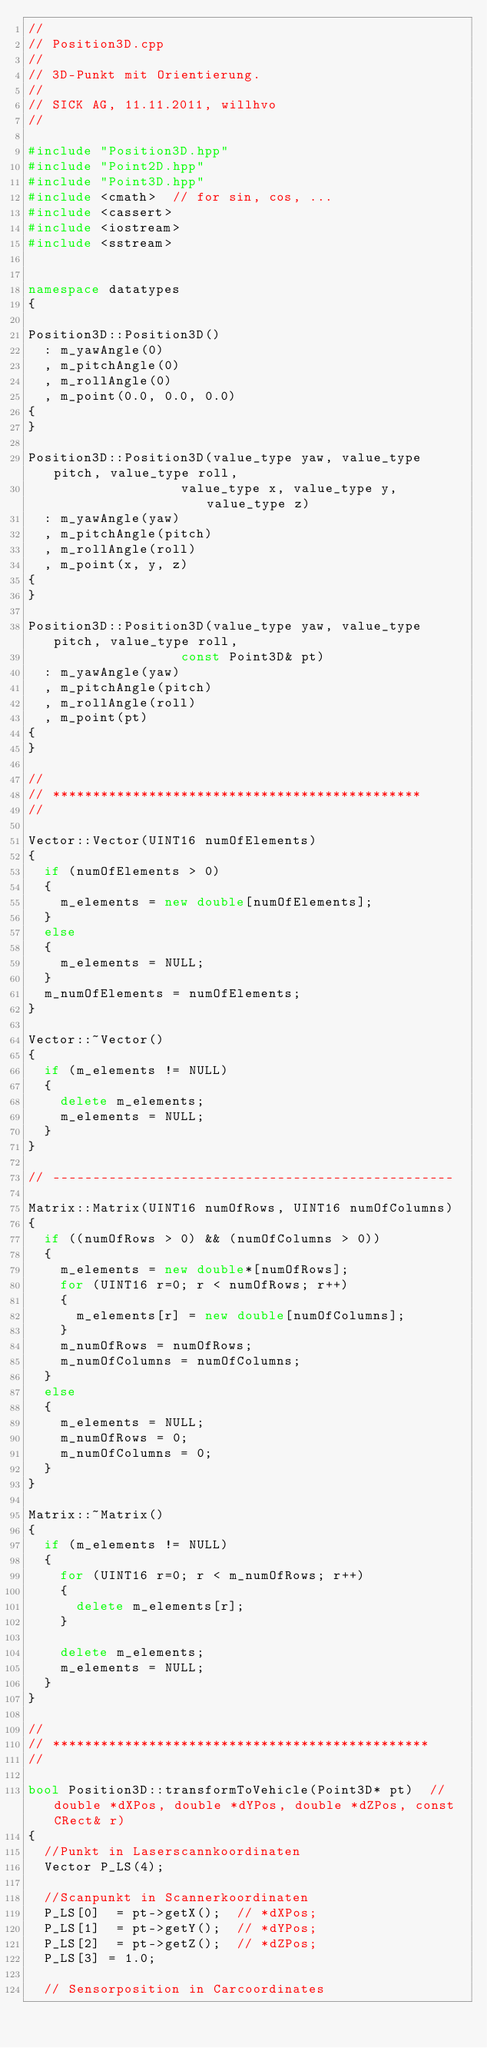Convert code to text. <code><loc_0><loc_0><loc_500><loc_500><_C++_>//
// Position3D.cpp
//
// 3D-Punkt mit Orientierung.
//
// SICK AG, 11.11.2011, willhvo
//

#include "Position3D.hpp"
#include "Point2D.hpp"
#include "Point3D.hpp"
#include <cmath>  // for sin, cos, ...
#include <cassert>
#include <iostream>
#include <sstream>


namespace datatypes
{
  
Position3D::Position3D()
  : m_yawAngle(0)
  , m_pitchAngle(0)
  , m_rollAngle(0)
  , m_point(0.0, 0.0, 0.0)
{
}

Position3D::Position3D(value_type yaw, value_type pitch, value_type roll,
                   value_type x, value_type y, value_type z)
  : m_yawAngle(yaw)
  , m_pitchAngle(pitch)
  , m_rollAngle(roll)
  , m_point(x, y, z)
{
}

Position3D::Position3D(value_type yaw, value_type pitch, value_type roll,
                   const Point3D& pt)
  : m_yawAngle(yaw)
  , m_pitchAngle(pitch)
  , m_rollAngle(roll)
  , m_point(pt)
{
}

//
// **********************************************
//

Vector::Vector(UINT16 numOfElements)
{
  if (numOfElements > 0)
  {
    m_elements = new double[numOfElements];
  }
  else
  {
    m_elements = NULL;
  }
  m_numOfElements = numOfElements;
}

Vector::~Vector()
{
  if (m_elements != NULL)
  {
    delete m_elements;
    m_elements = NULL;
  }
}

// --------------------------------------------------

Matrix::Matrix(UINT16 numOfRows, UINT16 numOfColumns)
{
  if ((numOfRows > 0) && (numOfColumns > 0))
  {
    m_elements = new double*[numOfRows];
    for (UINT16 r=0; r < numOfRows; r++)
    {
      m_elements[r] = new double[numOfColumns];
    }
    m_numOfRows = numOfRows;
    m_numOfColumns = numOfColumns;
  }
  else
  {
    m_elements = NULL;
    m_numOfRows = 0;
    m_numOfColumns = 0;
  }
}

Matrix::~Matrix()
{
  if (m_elements != NULL)
  {
    for (UINT16 r=0; r < m_numOfRows; r++)
    {
      delete m_elements[r];
    }
    
    delete m_elements;
    m_elements = NULL;
  }
}

//
// ***********************************************
//

bool Position3D::transformToVehicle(Point3D* pt)  // double *dXPos, double *dYPos, double *dZPos, const CRect& r)
{
  //Punkt in Laserscannkoordinaten
  Vector P_LS(4);

  //Scanpunkt in Scannerkoordinaten
  P_LS[0]  = pt->getX();  // *dXPos;
  P_LS[1]  = pt->getY();  // *dYPos;
  P_LS[2]  = pt->getZ();  // *dZPos;
  P_LS[3] = 1.0;

  // Sensorposition in Carcoordinates</code> 